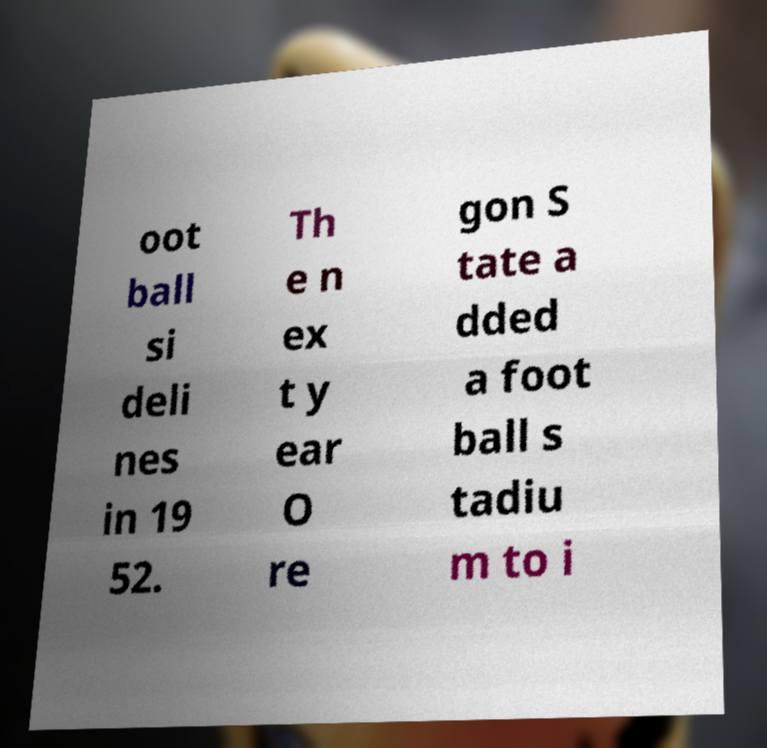Could you extract and type out the text from this image? oot ball si deli nes in 19 52. Th e n ex t y ear O re gon S tate a dded a foot ball s tadiu m to i 